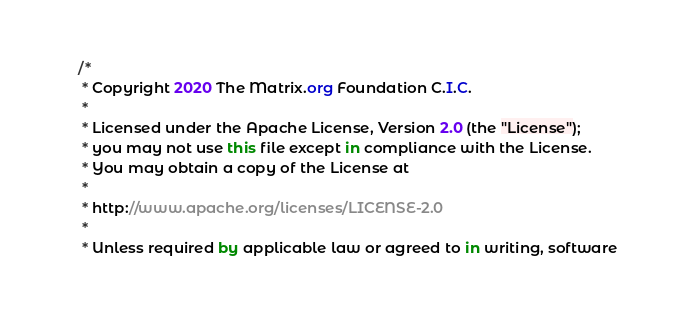<code> <loc_0><loc_0><loc_500><loc_500><_Kotlin_>/*
 * Copyright 2020 The Matrix.org Foundation C.I.C.
 *
 * Licensed under the Apache License, Version 2.0 (the "License");
 * you may not use this file except in compliance with the License.
 * You may obtain a copy of the License at
 *
 * http://www.apache.org/licenses/LICENSE-2.0
 *
 * Unless required by applicable law or agreed to in writing, software</code> 